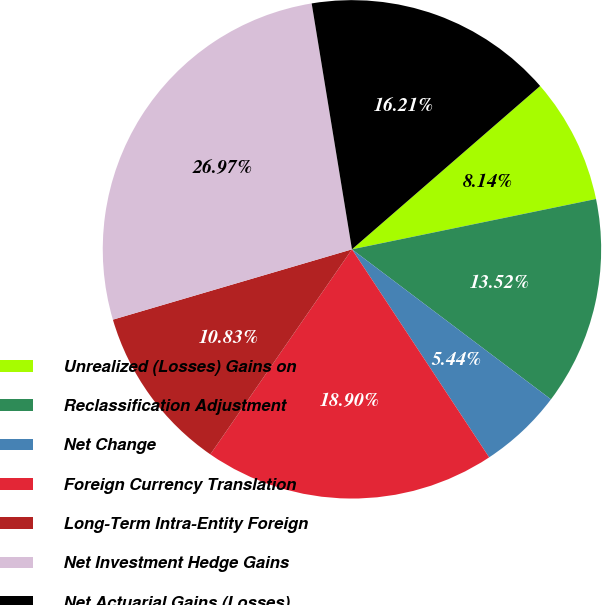Convert chart to OTSL. <chart><loc_0><loc_0><loc_500><loc_500><pie_chart><fcel>Unrealized (Losses) Gains on<fcel>Reclassification Adjustment<fcel>Net Change<fcel>Foreign Currency Translation<fcel>Long-Term Intra-Entity Foreign<fcel>Net Investment Hedge Gains<fcel>Net Actuarial Gains (Losses)<nl><fcel>8.14%<fcel>13.52%<fcel>5.44%<fcel>18.9%<fcel>10.83%<fcel>26.97%<fcel>16.21%<nl></chart> 